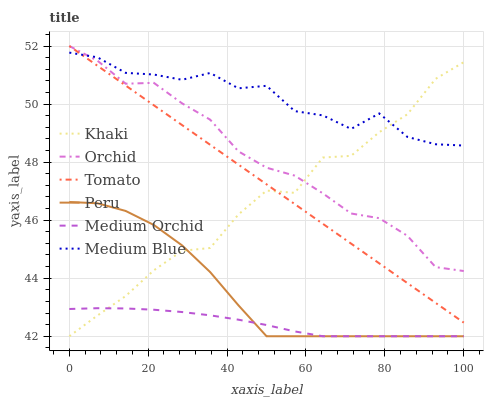Does Medium Orchid have the minimum area under the curve?
Answer yes or no. Yes. Does Medium Blue have the maximum area under the curve?
Answer yes or no. Yes. Does Khaki have the minimum area under the curve?
Answer yes or no. No. Does Khaki have the maximum area under the curve?
Answer yes or no. No. Is Tomato the smoothest?
Answer yes or no. Yes. Is Khaki the roughest?
Answer yes or no. Yes. Is Medium Orchid the smoothest?
Answer yes or no. No. Is Medium Orchid the roughest?
Answer yes or no. No. Does Medium Blue have the lowest value?
Answer yes or no. No. Does Orchid have the highest value?
Answer yes or no. Yes. Does Khaki have the highest value?
Answer yes or no. No. Is Medium Orchid less than Medium Blue?
Answer yes or no. Yes. Is Medium Blue greater than Medium Orchid?
Answer yes or no. Yes. Does Tomato intersect Medium Blue?
Answer yes or no. Yes. Is Tomato less than Medium Blue?
Answer yes or no. No. Is Tomato greater than Medium Blue?
Answer yes or no. No. Does Medium Orchid intersect Medium Blue?
Answer yes or no. No. 